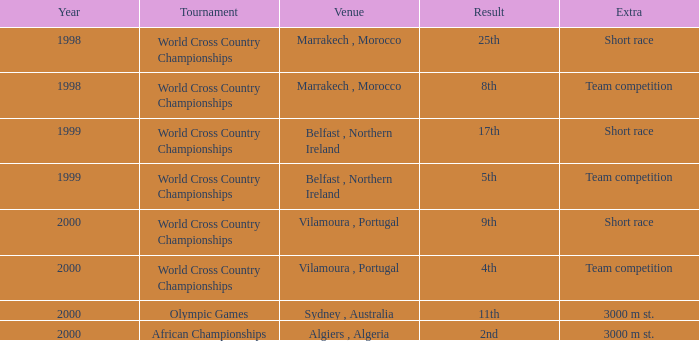What is the total of the years for the 5th result? 1999.0. 